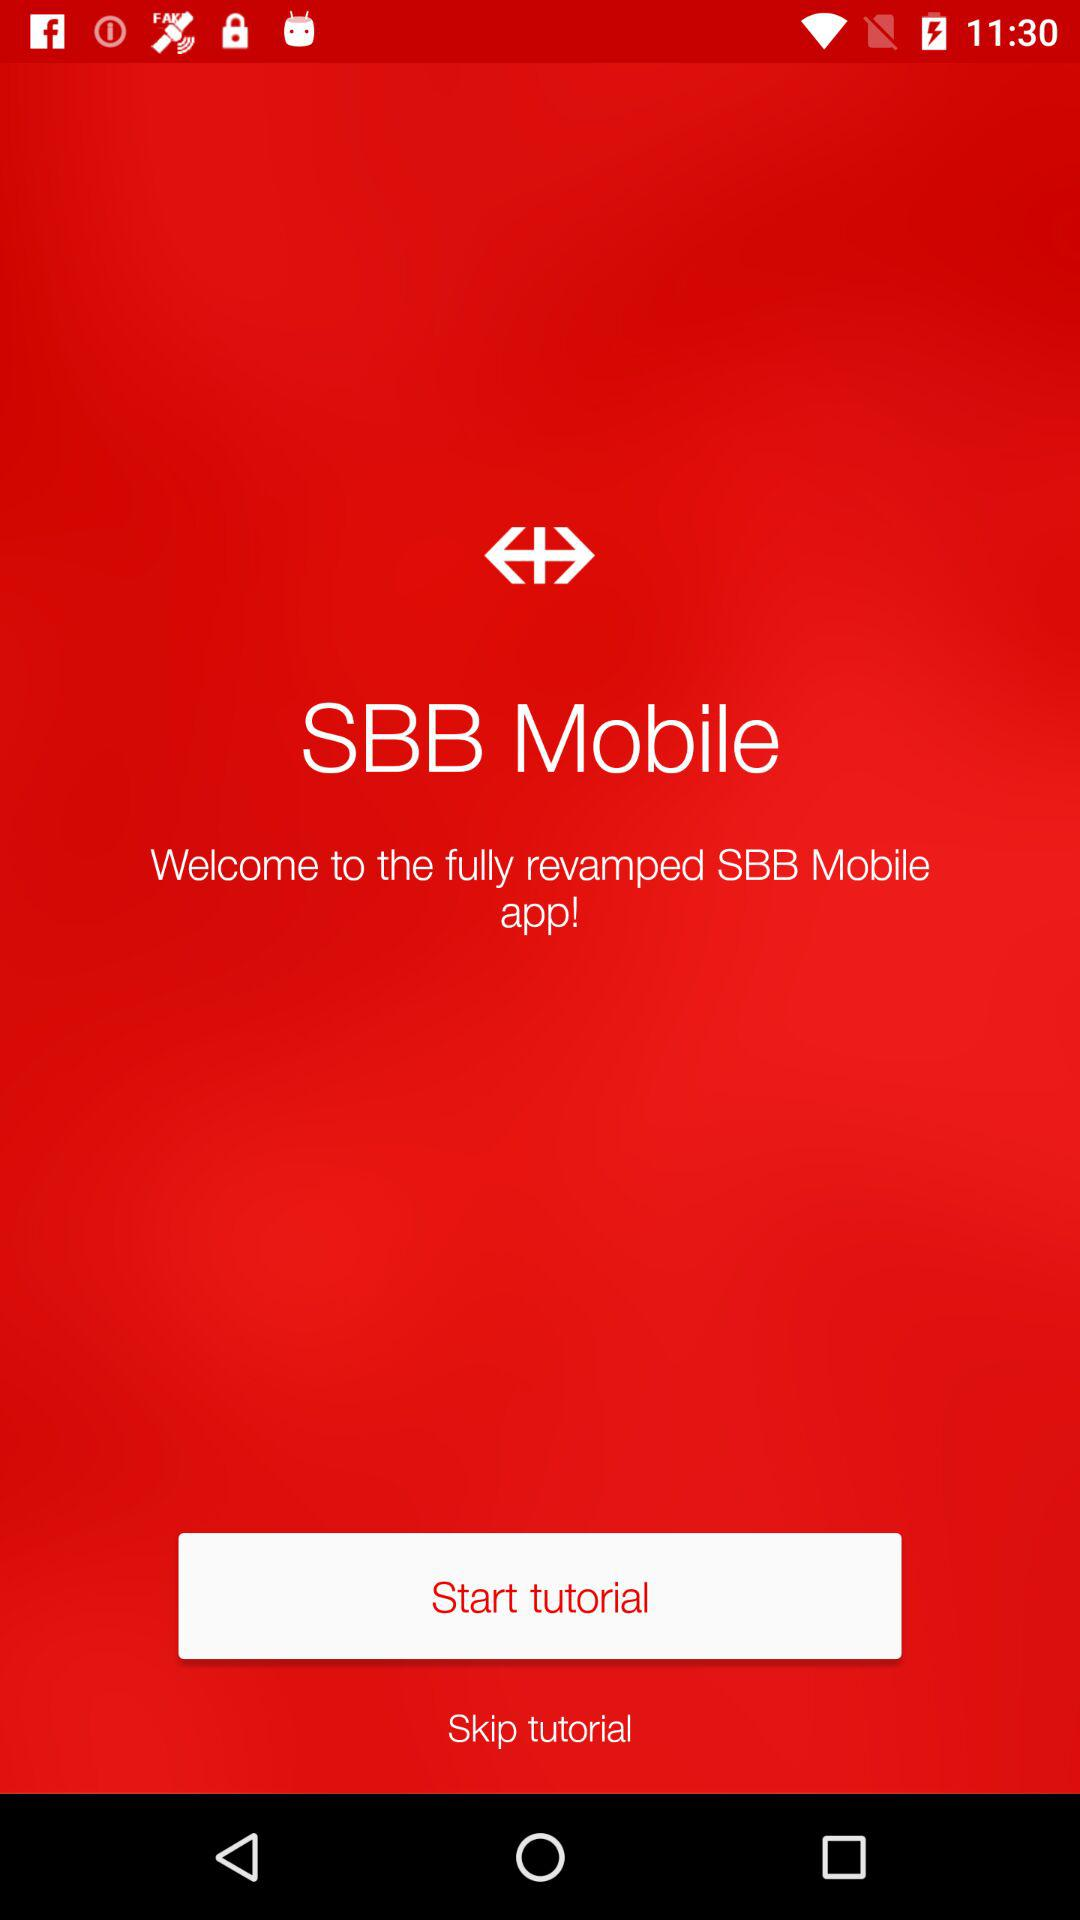What is the name of the application? The name of the application is "SBB Mobile". 